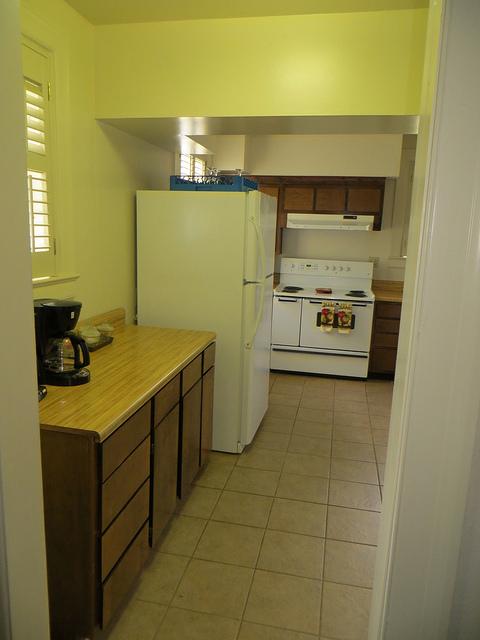Are the cabinets open or closed?
Give a very brief answer. Closed. Is this a bedroom?
Be succinct. No. What color has the owner used to accessorize the kitchen?
Short answer required. Yellow. How many drawers are next to the refrigerator?
Give a very brief answer. 7. What is the black splash made of?
Be succinct. Wood. What room is this?
Concise answer only. Kitchen. Is this kitchen functional?
Short answer required. Yes. What sports teams are represented on the fridge?
Quick response, please. 0. What color is the refrigerator?
Concise answer only. White. Is this a cheap house to live in?
Short answer required. Yes. What is this room?
Concise answer only. Kitchen. What color are the walls?
Write a very short answer. Yellow. What color is the is towel on the stove?
Give a very brief answer. White. What room is shown?
Write a very short answer. Kitchen. Does this kitchen has stainless steel appliances?
Keep it brief. No. 